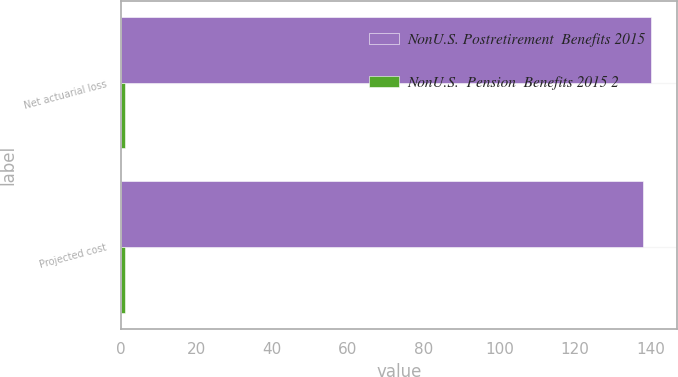Convert chart to OTSL. <chart><loc_0><loc_0><loc_500><loc_500><stacked_bar_chart><ecel><fcel>Net actuarial loss<fcel>Projected cost<nl><fcel>NonU.S. Postretirement  Benefits 2015<fcel>140<fcel>138<nl><fcel>NonU.S.  Pension  Benefits 2015 2<fcel>1<fcel>1<nl></chart> 